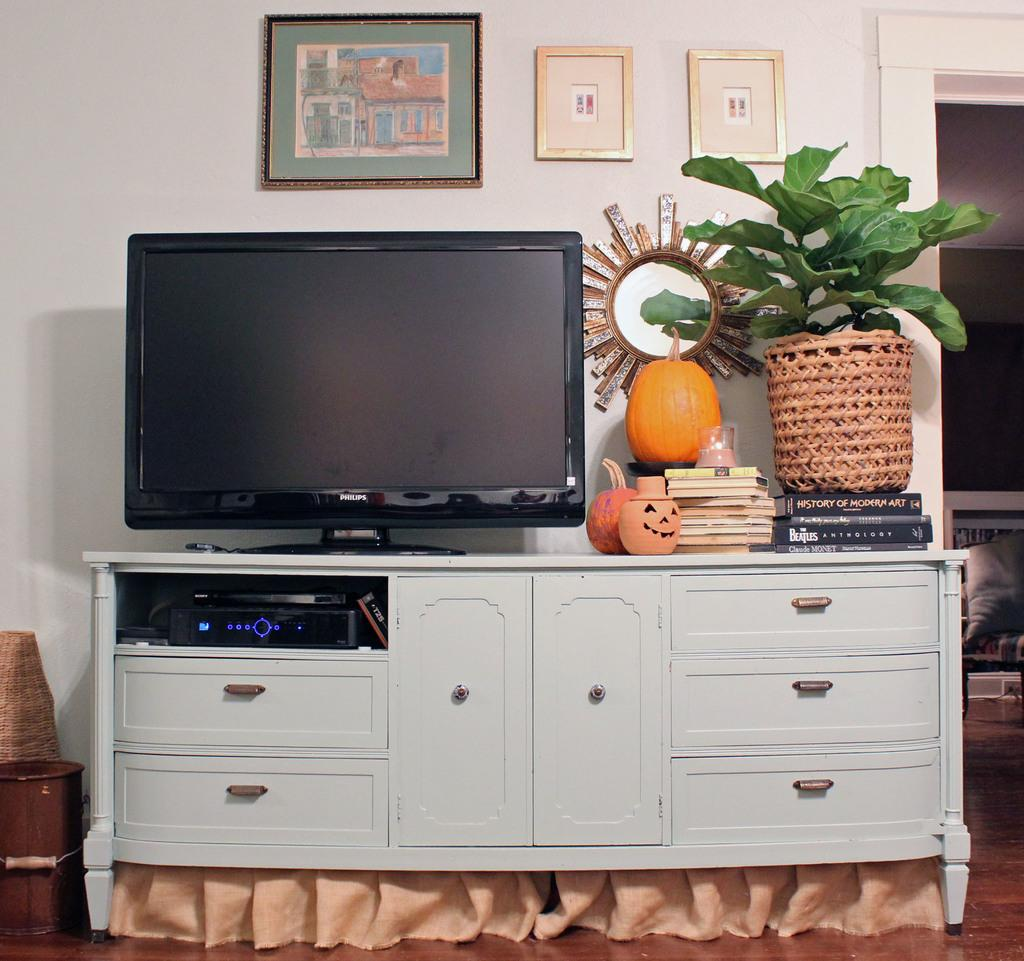What electronic device is visible in the image? There is a television in the image. What seasonal items can be seen in the image? There are pumpkins in the image. What type of plant is present in the image? There is a plant in a pot in the image. What items are stored on the cupboard in the image? There are books on a cupboard in the image. What device is used for playing DVDs in the image? There is a DVD player in the image. What reflective surface is present in the image? There is a mirror in the image. What decorative items are attached to the wall in the image? There are frames attached to the wall in the image. What type of alley can be seen in the image? There is no alley present in the image. 